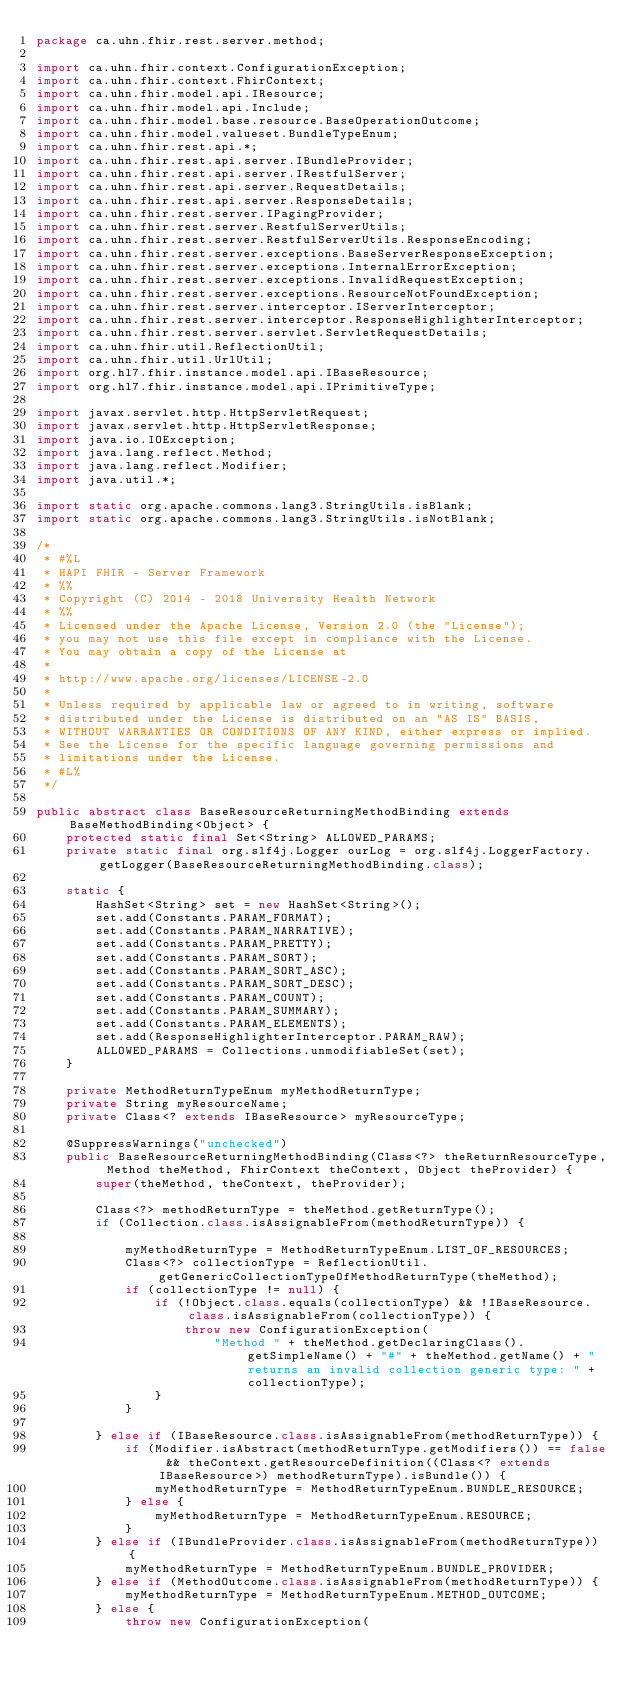<code> <loc_0><loc_0><loc_500><loc_500><_Java_>package ca.uhn.fhir.rest.server.method;

import ca.uhn.fhir.context.ConfigurationException;
import ca.uhn.fhir.context.FhirContext;
import ca.uhn.fhir.model.api.IResource;
import ca.uhn.fhir.model.api.Include;
import ca.uhn.fhir.model.base.resource.BaseOperationOutcome;
import ca.uhn.fhir.model.valueset.BundleTypeEnum;
import ca.uhn.fhir.rest.api.*;
import ca.uhn.fhir.rest.api.server.IBundleProvider;
import ca.uhn.fhir.rest.api.server.IRestfulServer;
import ca.uhn.fhir.rest.api.server.RequestDetails;
import ca.uhn.fhir.rest.api.server.ResponseDetails;
import ca.uhn.fhir.rest.server.IPagingProvider;
import ca.uhn.fhir.rest.server.RestfulServerUtils;
import ca.uhn.fhir.rest.server.RestfulServerUtils.ResponseEncoding;
import ca.uhn.fhir.rest.server.exceptions.BaseServerResponseException;
import ca.uhn.fhir.rest.server.exceptions.InternalErrorException;
import ca.uhn.fhir.rest.server.exceptions.InvalidRequestException;
import ca.uhn.fhir.rest.server.exceptions.ResourceNotFoundException;
import ca.uhn.fhir.rest.server.interceptor.IServerInterceptor;
import ca.uhn.fhir.rest.server.interceptor.ResponseHighlighterInterceptor;
import ca.uhn.fhir.rest.server.servlet.ServletRequestDetails;
import ca.uhn.fhir.util.ReflectionUtil;
import ca.uhn.fhir.util.UrlUtil;
import org.hl7.fhir.instance.model.api.IBaseResource;
import org.hl7.fhir.instance.model.api.IPrimitiveType;

import javax.servlet.http.HttpServletRequest;
import javax.servlet.http.HttpServletResponse;
import java.io.IOException;
import java.lang.reflect.Method;
import java.lang.reflect.Modifier;
import java.util.*;

import static org.apache.commons.lang3.StringUtils.isBlank;
import static org.apache.commons.lang3.StringUtils.isNotBlank;

/*
 * #%L
 * HAPI FHIR - Server Framework
 * %%
 * Copyright (C) 2014 - 2018 University Health Network
 * %%
 * Licensed under the Apache License, Version 2.0 (the "License");
 * you may not use this file except in compliance with the License.
 * You may obtain a copy of the License at
 * 
 * http://www.apache.org/licenses/LICENSE-2.0
 * 
 * Unless required by applicable law or agreed to in writing, software
 * distributed under the License is distributed on an "AS IS" BASIS,
 * WITHOUT WARRANTIES OR CONDITIONS OF ANY KIND, either express or implied.
 * See the License for the specific language governing permissions and
 * limitations under the License.
 * #L%
 */

public abstract class BaseResourceReturningMethodBinding extends BaseMethodBinding<Object> {
	protected static final Set<String> ALLOWED_PARAMS;
	private static final org.slf4j.Logger ourLog = org.slf4j.LoggerFactory.getLogger(BaseResourceReturningMethodBinding.class);

	static {
		HashSet<String> set = new HashSet<String>();
		set.add(Constants.PARAM_FORMAT);
		set.add(Constants.PARAM_NARRATIVE);
		set.add(Constants.PARAM_PRETTY);
		set.add(Constants.PARAM_SORT);
		set.add(Constants.PARAM_SORT_ASC);
		set.add(Constants.PARAM_SORT_DESC);
		set.add(Constants.PARAM_COUNT);
		set.add(Constants.PARAM_SUMMARY);
		set.add(Constants.PARAM_ELEMENTS);
		set.add(ResponseHighlighterInterceptor.PARAM_RAW);
		ALLOWED_PARAMS = Collections.unmodifiableSet(set);
	}

	private MethodReturnTypeEnum myMethodReturnType;
	private String myResourceName;
	private Class<? extends IBaseResource> myResourceType;

	@SuppressWarnings("unchecked")
	public BaseResourceReturningMethodBinding(Class<?> theReturnResourceType, Method theMethod, FhirContext theContext, Object theProvider) {
		super(theMethod, theContext, theProvider);

		Class<?> methodReturnType = theMethod.getReturnType();
		if (Collection.class.isAssignableFrom(methodReturnType)) {

			myMethodReturnType = MethodReturnTypeEnum.LIST_OF_RESOURCES;
			Class<?> collectionType = ReflectionUtil.getGenericCollectionTypeOfMethodReturnType(theMethod);
			if (collectionType != null) {
				if (!Object.class.equals(collectionType) && !IBaseResource.class.isAssignableFrom(collectionType)) {
					throw new ConfigurationException(
						"Method " + theMethod.getDeclaringClass().getSimpleName() + "#" + theMethod.getName() + " returns an invalid collection generic type: " + collectionType);
				}
			}

		} else if (IBaseResource.class.isAssignableFrom(methodReturnType)) {
			if (Modifier.isAbstract(methodReturnType.getModifiers()) == false && theContext.getResourceDefinition((Class<? extends IBaseResource>) methodReturnType).isBundle()) {
				myMethodReturnType = MethodReturnTypeEnum.BUNDLE_RESOURCE;
			} else {
				myMethodReturnType = MethodReturnTypeEnum.RESOURCE;
			}
		} else if (IBundleProvider.class.isAssignableFrom(methodReturnType)) {
			myMethodReturnType = MethodReturnTypeEnum.BUNDLE_PROVIDER;
		} else if (MethodOutcome.class.isAssignableFrom(methodReturnType)) {
			myMethodReturnType = MethodReturnTypeEnum.METHOD_OUTCOME;
		} else {
			throw new ConfigurationException(</code> 